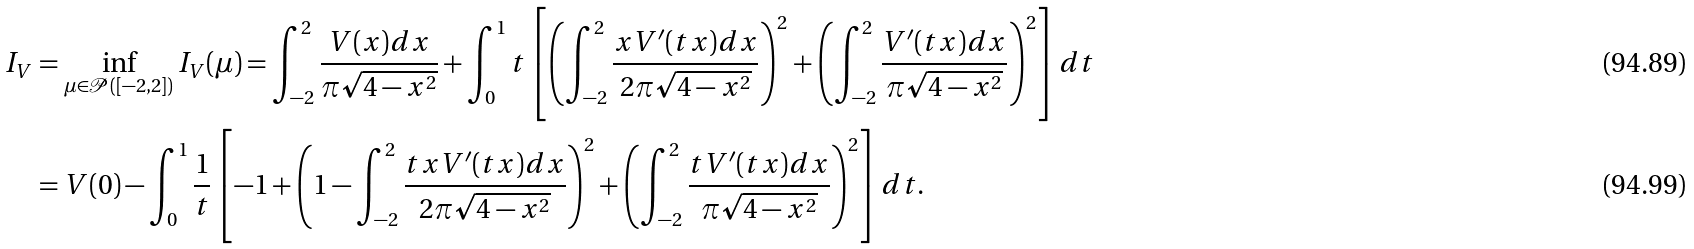<formula> <loc_0><loc_0><loc_500><loc_500>I _ { V } & = \inf _ { \mu \in \mathcal { P } ( [ - 2 , 2 ] ) } I _ { V } ( \mu ) = \int _ { - 2 } ^ { 2 } \frac { V ( x ) d x } { \pi \sqrt { 4 - x ^ { 2 } } } + \int _ { 0 } ^ { 1 } t \left [ \left ( \int _ { - 2 } ^ { 2 } \frac { x V ^ { \prime } ( t x ) d x } { 2 \pi \sqrt { 4 - x ^ { 2 } } } \right ) ^ { 2 } + \left ( \int _ { - 2 } ^ { 2 } \frac { V ^ { \prime } ( t x ) d x } { \pi \sqrt { 4 - x ^ { 2 } } } \right ) ^ { 2 } \right ] d t \\ & = V ( 0 ) - \int _ { 0 } ^ { 1 } \frac { 1 } { t } \left [ - 1 + \left ( 1 - \int _ { - 2 } ^ { 2 } \frac { t x V ^ { \prime } ( t x ) d x } { 2 \pi \sqrt { 4 - x ^ { 2 } } } \right ) ^ { 2 } + \left ( \int _ { - 2 } ^ { 2 } \frac { t V ^ { \prime } ( t x ) d x } { \pi \sqrt { 4 - x ^ { 2 } } } \right ) ^ { 2 } \right ] d t .</formula> 